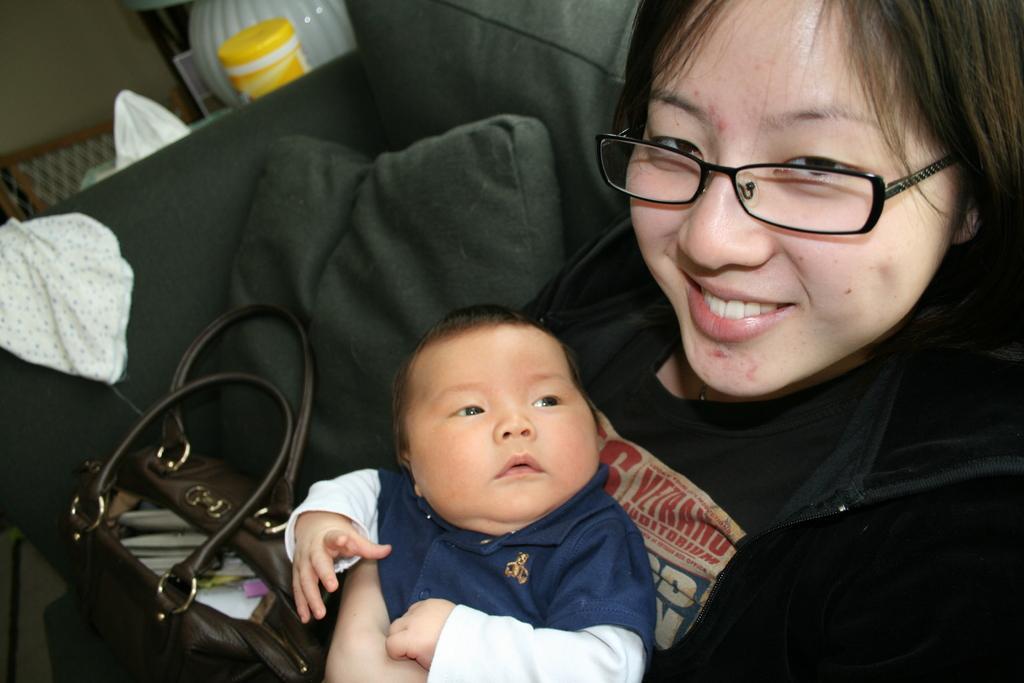Can you describe this image briefly? In this image i can see a woman wearing a black t shirt and black jacket sitting on a couch, and holding a baby. On the couch i can see a cushion and a bag. In the background i can see few clothes , few objects and the wall. 